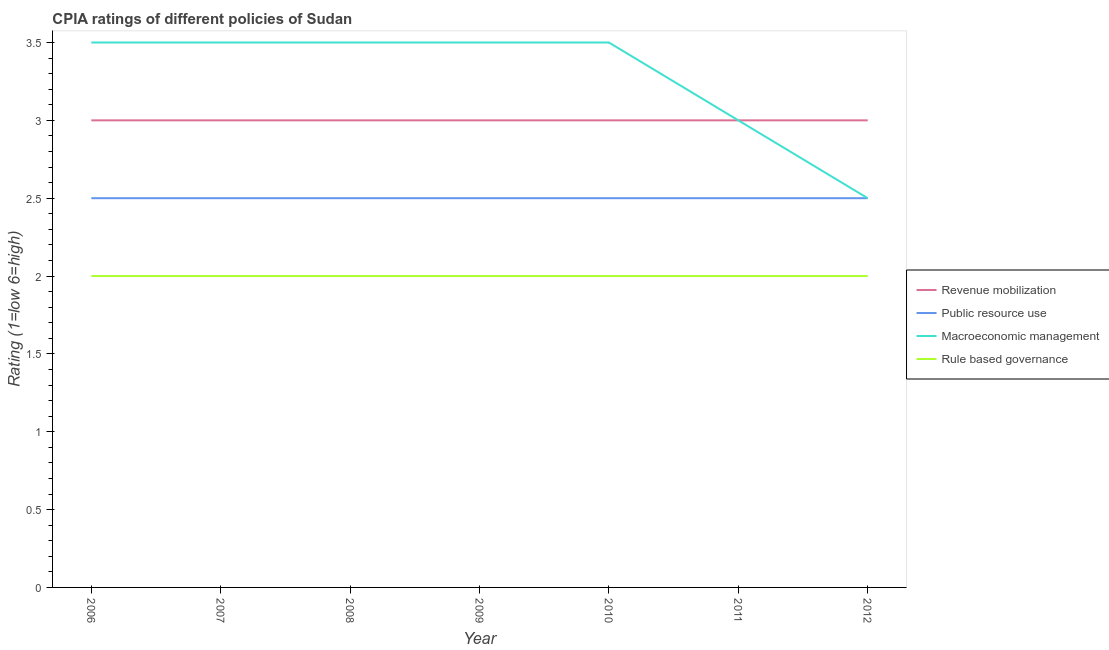How many different coloured lines are there?
Make the answer very short. 4. Does the line corresponding to cpia rating of revenue mobilization intersect with the line corresponding to cpia rating of rule based governance?
Offer a very short reply. No. What is the cpia rating of revenue mobilization in 2008?
Keep it short and to the point. 3. Across all years, what is the maximum cpia rating of revenue mobilization?
Your answer should be very brief. 3. Across all years, what is the minimum cpia rating of revenue mobilization?
Offer a very short reply. 3. In which year was the cpia rating of macroeconomic management maximum?
Provide a short and direct response. 2006. In which year was the cpia rating of public resource use minimum?
Your answer should be compact. 2006. What is the difference between the cpia rating of public resource use in 2009 and that in 2012?
Keep it short and to the point. 0. What is the difference between the cpia rating of rule based governance in 2006 and the cpia rating of macroeconomic management in 2010?
Keep it short and to the point. -1.5. What is the ratio of the cpia rating of revenue mobilization in 2007 to that in 2009?
Provide a succinct answer. 1. In how many years, is the cpia rating of public resource use greater than the average cpia rating of public resource use taken over all years?
Give a very brief answer. 0. Is it the case that in every year, the sum of the cpia rating of macroeconomic management and cpia rating of public resource use is greater than the sum of cpia rating of rule based governance and cpia rating of revenue mobilization?
Ensure brevity in your answer.  No. Does the cpia rating of rule based governance monotonically increase over the years?
Offer a very short reply. No. What is the difference between two consecutive major ticks on the Y-axis?
Give a very brief answer. 0.5. Does the graph contain any zero values?
Your response must be concise. No. Does the graph contain grids?
Your answer should be very brief. No. Where does the legend appear in the graph?
Offer a terse response. Center right. How many legend labels are there?
Your answer should be compact. 4. What is the title of the graph?
Keep it short and to the point. CPIA ratings of different policies of Sudan. Does "Public resource use" appear as one of the legend labels in the graph?
Offer a very short reply. Yes. What is the label or title of the X-axis?
Offer a very short reply. Year. What is the Rating (1=low 6=high) of Public resource use in 2006?
Provide a short and direct response. 2.5. What is the Rating (1=low 6=high) in Macroeconomic management in 2006?
Offer a very short reply. 3.5. What is the Rating (1=low 6=high) of Rule based governance in 2006?
Give a very brief answer. 2. What is the Rating (1=low 6=high) of Revenue mobilization in 2007?
Provide a short and direct response. 3. What is the Rating (1=low 6=high) of Rule based governance in 2007?
Make the answer very short. 2. What is the Rating (1=low 6=high) in Revenue mobilization in 2008?
Provide a succinct answer. 3. What is the Rating (1=low 6=high) in Macroeconomic management in 2008?
Your response must be concise. 3.5. What is the Rating (1=low 6=high) in Revenue mobilization in 2009?
Ensure brevity in your answer.  3. What is the Rating (1=low 6=high) in Public resource use in 2009?
Ensure brevity in your answer.  2.5. What is the Rating (1=low 6=high) of Macroeconomic management in 2009?
Offer a very short reply. 3.5. What is the Rating (1=low 6=high) of Rule based governance in 2009?
Offer a terse response. 2. What is the Rating (1=low 6=high) of Revenue mobilization in 2011?
Offer a terse response. 3. What is the Rating (1=low 6=high) in Public resource use in 2011?
Offer a terse response. 2.5. What is the Rating (1=low 6=high) of Macroeconomic management in 2011?
Provide a succinct answer. 3. What is the Rating (1=low 6=high) in Revenue mobilization in 2012?
Your answer should be very brief. 3. What is the Rating (1=low 6=high) in Macroeconomic management in 2012?
Your answer should be compact. 2.5. Across all years, what is the maximum Rating (1=low 6=high) of Public resource use?
Provide a short and direct response. 2.5. Across all years, what is the maximum Rating (1=low 6=high) in Rule based governance?
Provide a short and direct response. 2. Across all years, what is the minimum Rating (1=low 6=high) in Revenue mobilization?
Your answer should be compact. 3. What is the total Rating (1=low 6=high) in Macroeconomic management in the graph?
Offer a very short reply. 23. What is the difference between the Rating (1=low 6=high) in Macroeconomic management in 2006 and that in 2007?
Your answer should be compact. 0. What is the difference between the Rating (1=low 6=high) in Rule based governance in 2006 and that in 2007?
Keep it short and to the point. 0. What is the difference between the Rating (1=low 6=high) in Revenue mobilization in 2006 and that in 2008?
Provide a short and direct response. 0. What is the difference between the Rating (1=low 6=high) of Public resource use in 2006 and that in 2008?
Give a very brief answer. 0. What is the difference between the Rating (1=low 6=high) in Macroeconomic management in 2006 and that in 2008?
Ensure brevity in your answer.  0. What is the difference between the Rating (1=low 6=high) in Rule based governance in 2006 and that in 2008?
Offer a very short reply. 0. What is the difference between the Rating (1=low 6=high) of Revenue mobilization in 2006 and that in 2009?
Provide a short and direct response. 0. What is the difference between the Rating (1=low 6=high) in Public resource use in 2006 and that in 2009?
Provide a short and direct response. 0. What is the difference between the Rating (1=low 6=high) of Macroeconomic management in 2006 and that in 2009?
Your answer should be compact. 0. What is the difference between the Rating (1=low 6=high) in Rule based governance in 2006 and that in 2009?
Make the answer very short. 0. What is the difference between the Rating (1=low 6=high) in Revenue mobilization in 2006 and that in 2010?
Your answer should be compact. 0. What is the difference between the Rating (1=low 6=high) of Public resource use in 2006 and that in 2010?
Your response must be concise. 0. What is the difference between the Rating (1=low 6=high) in Rule based governance in 2006 and that in 2010?
Ensure brevity in your answer.  0. What is the difference between the Rating (1=low 6=high) in Public resource use in 2006 and that in 2011?
Make the answer very short. 0. What is the difference between the Rating (1=low 6=high) of Macroeconomic management in 2006 and that in 2011?
Make the answer very short. 0.5. What is the difference between the Rating (1=low 6=high) in Rule based governance in 2006 and that in 2011?
Your answer should be compact. 0. What is the difference between the Rating (1=low 6=high) of Revenue mobilization in 2006 and that in 2012?
Keep it short and to the point. 0. What is the difference between the Rating (1=low 6=high) of Macroeconomic management in 2006 and that in 2012?
Provide a short and direct response. 1. What is the difference between the Rating (1=low 6=high) of Rule based governance in 2006 and that in 2012?
Ensure brevity in your answer.  0. What is the difference between the Rating (1=low 6=high) of Revenue mobilization in 2007 and that in 2009?
Your answer should be compact. 0. What is the difference between the Rating (1=low 6=high) in Rule based governance in 2007 and that in 2009?
Provide a succinct answer. 0. What is the difference between the Rating (1=low 6=high) in Macroeconomic management in 2007 and that in 2010?
Provide a short and direct response. 0. What is the difference between the Rating (1=low 6=high) in Rule based governance in 2007 and that in 2010?
Your answer should be compact. 0. What is the difference between the Rating (1=low 6=high) of Public resource use in 2007 and that in 2011?
Provide a short and direct response. 0. What is the difference between the Rating (1=low 6=high) in Rule based governance in 2007 and that in 2011?
Offer a terse response. 0. What is the difference between the Rating (1=low 6=high) in Public resource use in 2007 and that in 2012?
Provide a short and direct response. 0. What is the difference between the Rating (1=low 6=high) in Macroeconomic management in 2007 and that in 2012?
Keep it short and to the point. 1. What is the difference between the Rating (1=low 6=high) of Rule based governance in 2007 and that in 2012?
Keep it short and to the point. 0. What is the difference between the Rating (1=low 6=high) in Revenue mobilization in 2008 and that in 2009?
Ensure brevity in your answer.  0. What is the difference between the Rating (1=low 6=high) in Macroeconomic management in 2008 and that in 2009?
Provide a short and direct response. 0. What is the difference between the Rating (1=low 6=high) of Public resource use in 2008 and that in 2010?
Your response must be concise. 0. What is the difference between the Rating (1=low 6=high) of Rule based governance in 2008 and that in 2010?
Provide a succinct answer. 0. What is the difference between the Rating (1=low 6=high) of Public resource use in 2008 and that in 2011?
Make the answer very short. 0. What is the difference between the Rating (1=low 6=high) in Macroeconomic management in 2008 and that in 2011?
Provide a short and direct response. 0.5. What is the difference between the Rating (1=low 6=high) of Rule based governance in 2008 and that in 2011?
Offer a very short reply. 0. What is the difference between the Rating (1=low 6=high) of Macroeconomic management in 2008 and that in 2012?
Keep it short and to the point. 1. What is the difference between the Rating (1=low 6=high) in Revenue mobilization in 2009 and that in 2010?
Offer a terse response. 0. What is the difference between the Rating (1=low 6=high) in Public resource use in 2009 and that in 2010?
Keep it short and to the point. 0. What is the difference between the Rating (1=low 6=high) in Macroeconomic management in 2009 and that in 2010?
Give a very brief answer. 0. What is the difference between the Rating (1=low 6=high) in Revenue mobilization in 2009 and that in 2011?
Keep it short and to the point. 0. What is the difference between the Rating (1=low 6=high) in Revenue mobilization in 2009 and that in 2012?
Offer a very short reply. 0. What is the difference between the Rating (1=low 6=high) in Rule based governance in 2010 and that in 2011?
Your response must be concise. 0. What is the difference between the Rating (1=low 6=high) of Public resource use in 2010 and that in 2012?
Your answer should be compact. 0. What is the difference between the Rating (1=low 6=high) in Macroeconomic management in 2010 and that in 2012?
Your answer should be compact. 1. What is the difference between the Rating (1=low 6=high) in Public resource use in 2011 and that in 2012?
Offer a very short reply. 0. What is the difference between the Rating (1=low 6=high) of Macroeconomic management in 2011 and that in 2012?
Make the answer very short. 0.5. What is the difference between the Rating (1=low 6=high) of Revenue mobilization in 2006 and the Rating (1=low 6=high) of Public resource use in 2007?
Offer a terse response. 0.5. What is the difference between the Rating (1=low 6=high) of Public resource use in 2006 and the Rating (1=low 6=high) of Macroeconomic management in 2007?
Make the answer very short. -1. What is the difference between the Rating (1=low 6=high) of Macroeconomic management in 2006 and the Rating (1=low 6=high) of Rule based governance in 2007?
Make the answer very short. 1.5. What is the difference between the Rating (1=low 6=high) in Revenue mobilization in 2006 and the Rating (1=low 6=high) in Public resource use in 2008?
Your response must be concise. 0.5. What is the difference between the Rating (1=low 6=high) in Revenue mobilization in 2006 and the Rating (1=low 6=high) in Rule based governance in 2008?
Your answer should be compact. 1. What is the difference between the Rating (1=low 6=high) of Public resource use in 2006 and the Rating (1=low 6=high) of Macroeconomic management in 2009?
Your response must be concise. -1. What is the difference between the Rating (1=low 6=high) in Macroeconomic management in 2006 and the Rating (1=low 6=high) in Rule based governance in 2009?
Keep it short and to the point. 1.5. What is the difference between the Rating (1=low 6=high) of Revenue mobilization in 2006 and the Rating (1=low 6=high) of Macroeconomic management in 2010?
Offer a very short reply. -0.5. What is the difference between the Rating (1=low 6=high) in Revenue mobilization in 2006 and the Rating (1=low 6=high) in Rule based governance in 2010?
Offer a terse response. 1. What is the difference between the Rating (1=low 6=high) in Public resource use in 2006 and the Rating (1=low 6=high) in Rule based governance in 2011?
Give a very brief answer. 0.5. What is the difference between the Rating (1=low 6=high) of Macroeconomic management in 2006 and the Rating (1=low 6=high) of Rule based governance in 2011?
Your answer should be very brief. 1.5. What is the difference between the Rating (1=low 6=high) of Revenue mobilization in 2006 and the Rating (1=low 6=high) of Macroeconomic management in 2012?
Give a very brief answer. 0.5. What is the difference between the Rating (1=low 6=high) in Macroeconomic management in 2006 and the Rating (1=low 6=high) in Rule based governance in 2012?
Give a very brief answer. 1.5. What is the difference between the Rating (1=low 6=high) of Public resource use in 2007 and the Rating (1=low 6=high) of Macroeconomic management in 2008?
Provide a succinct answer. -1. What is the difference between the Rating (1=low 6=high) of Revenue mobilization in 2007 and the Rating (1=low 6=high) of Public resource use in 2009?
Provide a succinct answer. 0.5. What is the difference between the Rating (1=low 6=high) of Revenue mobilization in 2007 and the Rating (1=low 6=high) of Rule based governance in 2009?
Offer a terse response. 1. What is the difference between the Rating (1=low 6=high) in Revenue mobilization in 2007 and the Rating (1=low 6=high) in Macroeconomic management in 2010?
Ensure brevity in your answer.  -0.5. What is the difference between the Rating (1=low 6=high) in Revenue mobilization in 2007 and the Rating (1=low 6=high) in Rule based governance in 2010?
Provide a short and direct response. 1. What is the difference between the Rating (1=low 6=high) of Public resource use in 2007 and the Rating (1=low 6=high) of Macroeconomic management in 2010?
Your answer should be very brief. -1. What is the difference between the Rating (1=low 6=high) of Public resource use in 2007 and the Rating (1=low 6=high) of Rule based governance in 2010?
Your response must be concise. 0.5. What is the difference between the Rating (1=low 6=high) of Revenue mobilization in 2007 and the Rating (1=low 6=high) of Public resource use in 2011?
Your answer should be very brief. 0.5. What is the difference between the Rating (1=low 6=high) of Public resource use in 2007 and the Rating (1=low 6=high) of Macroeconomic management in 2011?
Your answer should be very brief. -0.5. What is the difference between the Rating (1=low 6=high) of Macroeconomic management in 2007 and the Rating (1=low 6=high) of Rule based governance in 2011?
Your answer should be compact. 1.5. What is the difference between the Rating (1=low 6=high) in Revenue mobilization in 2007 and the Rating (1=low 6=high) in Public resource use in 2012?
Your answer should be very brief. 0.5. What is the difference between the Rating (1=low 6=high) in Revenue mobilization in 2007 and the Rating (1=low 6=high) in Rule based governance in 2012?
Give a very brief answer. 1. What is the difference between the Rating (1=low 6=high) of Public resource use in 2007 and the Rating (1=low 6=high) of Rule based governance in 2012?
Make the answer very short. 0.5. What is the difference between the Rating (1=low 6=high) in Macroeconomic management in 2008 and the Rating (1=low 6=high) in Rule based governance in 2009?
Give a very brief answer. 1.5. What is the difference between the Rating (1=low 6=high) in Revenue mobilization in 2008 and the Rating (1=low 6=high) in Public resource use in 2010?
Offer a terse response. 0.5. What is the difference between the Rating (1=low 6=high) of Revenue mobilization in 2008 and the Rating (1=low 6=high) of Macroeconomic management in 2010?
Keep it short and to the point. -0.5. What is the difference between the Rating (1=low 6=high) in Revenue mobilization in 2008 and the Rating (1=low 6=high) in Rule based governance in 2010?
Your answer should be compact. 1. What is the difference between the Rating (1=low 6=high) in Macroeconomic management in 2008 and the Rating (1=low 6=high) in Rule based governance in 2010?
Offer a very short reply. 1.5. What is the difference between the Rating (1=low 6=high) in Revenue mobilization in 2008 and the Rating (1=low 6=high) in Public resource use in 2011?
Give a very brief answer. 0.5. What is the difference between the Rating (1=low 6=high) of Public resource use in 2008 and the Rating (1=low 6=high) of Macroeconomic management in 2011?
Give a very brief answer. -0.5. What is the difference between the Rating (1=low 6=high) of Macroeconomic management in 2008 and the Rating (1=low 6=high) of Rule based governance in 2011?
Provide a succinct answer. 1.5. What is the difference between the Rating (1=low 6=high) in Revenue mobilization in 2008 and the Rating (1=low 6=high) in Public resource use in 2012?
Your answer should be very brief. 0.5. What is the difference between the Rating (1=low 6=high) of Revenue mobilization in 2008 and the Rating (1=low 6=high) of Macroeconomic management in 2012?
Make the answer very short. 0.5. What is the difference between the Rating (1=low 6=high) of Macroeconomic management in 2008 and the Rating (1=low 6=high) of Rule based governance in 2012?
Your answer should be compact. 1.5. What is the difference between the Rating (1=low 6=high) of Revenue mobilization in 2009 and the Rating (1=low 6=high) of Public resource use in 2010?
Give a very brief answer. 0.5. What is the difference between the Rating (1=low 6=high) in Public resource use in 2009 and the Rating (1=low 6=high) in Macroeconomic management in 2010?
Offer a terse response. -1. What is the difference between the Rating (1=low 6=high) in Public resource use in 2009 and the Rating (1=low 6=high) in Rule based governance in 2010?
Your answer should be very brief. 0.5. What is the difference between the Rating (1=low 6=high) of Public resource use in 2009 and the Rating (1=low 6=high) of Macroeconomic management in 2011?
Keep it short and to the point. -0.5. What is the difference between the Rating (1=low 6=high) in Public resource use in 2009 and the Rating (1=low 6=high) in Rule based governance in 2011?
Your answer should be very brief. 0.5. What is the difference between the Rating (1=low 6=high) in Macroeconomic management in 2009 and the Rating (1=low 6=high) in Rule based governance in 2011?
Provide a succinct answer. 1.5. What is the difference between the Rating (1=low 6=high) in Revenue mobilization in 2009 and the Rating (1=low 6=high) in Public resource use in 2012?
Offer a very short reply. 0.5. What is the difference between the Rating (1=low 6=high) of Revenue mobilization in 2009 and the Rating (1=low 6=high) of Rule based governance in 2012?
Your answer should be compact. 1. What is the difference between the Rating (1=low 6=high) of Public resource use in 2009 and the Rating (1=low 6=high) of Macroeconomic management in 2012?
Your answer should be very brief. 0. What is the difference between the Rating (1=low 6=high) in Macroeconomic management in 2009 and the Rating (1=low 6=high) in Rule based governance in 2012?
Make the answer very short. 1.5. What is the difference between the Rating (1=low 6=high) of Revenue mobilization in 2010 and the Rating (1=low 6=high) of Public resource use in 2011?
Provide a short and direct response. 0.5. What is the difference between the Rating (1=low 6=high) in Public resource use in 2010 and the Rating (1=low 6=high) in Macroeconomic management in 2011?
Provide a short and direct response. -0.5. What is the difference between the Rating (1=low 6=high) in Public resource use in 2010 and the Rating (1=low 6=high) in Rule based governance in 2011?
Your response must be concise. 0.5. What is the difference between the Rating (1=low 6=high) in Revenue mobilization in 2010 and the Rating (1=low 6=high) in Public resource use in 2012?
Provide a short and direct response. 0.5. What is the difference between the Rating (1=low 6=high) in Revenue mobilization in 2010 and the Rating (1=low 6=high) in Rule based governance in 2012?
Offer a terse response. 1. What is the difference between the Rating (1=low 6=high) in Public resource use in 2010 and the Rating (1=low 6=high) in Macroeconomic management in 2012?
Keep it short and to the point. 0. What is the difference between the Rating (1=low 6=high) in Public resource use in 2010 and the Rating (1=low 6=high) in Rule based governance in 2012?
Provide a succinct answer. 0.5. What is the difference between the Rating (1=low 6=high) of Macroeconomic management in 2010 and the Rating (1=low 6=high) of Rule based governance in 2012?
Offer a very short reply. 1.5. What is the difference between the Rating (1=low 6=high) of Revenue mobilization in 2011 and the Rating (1=low 6=high) of Rule based governance in 2012?
Your answer should be very brief. 1. What is the difference between the Rating (1=low 6=high) in Public resource use in 2011 and the Rating (1=low 6=high) in Macroeconomic management in 2012?
Ensure brevity in your answer.  0. What is the difference between the Rating (1=low 6=high) in Public resource use in 2011 and the Rating (1=low 6=high) in Rule based governance in 2012?
Make the answer very short. 0.5. What is the average Rating (1=low 6=high) of Revenue mobilization per year?
Offer a terse response. 3. What is the average Rating (1=low 6=high) of Public resource use per year?
Your answer should be very brief. 2.5. What is the average Rating (1=low 6=high) of Macroeconomic management per year?
Provide a short and direct response. 3.29. What is the average Rating (1=low 6=high) in Rule based governance per year?
Give a very brief answer. 2. In the year 2006, what is the difference between the Rating (1=low 6=high) of Public resource use and Rating (1=low 6=high) of Macroeconomic management?
Ensure brevity in your answer.  -1. In the year 2007, what is the difference between the Rating (1=low 6=high) in Revenue mobilization and Rating (1=low 6=high) in Public resource use?
Provide a succinct answer. 0.5. In the year 2007, what is the difference between the Rating (1=low 6=high) in Revenue mobilization and Rating (1=low 6=high) in Macroeconomic management?
Keep it short and to the point. -0.5. In the year 2007, what is the difference between the Rating (1=low 6=high) of Public resource use and Rating (1=low 6=high) of Macroeconomic management?
Your answer should be compact. -1. In the year 2007, what is the difference between the Rating (1=low 6=high) in Public resource use and Rating (1=low 6=high) in Rule based governance?
Give a very brief answer. 0.5. In the year 2007, what is the difference between the Rating (1=low 6=high) of Macroeconomic management and Rating (1=low 6=high) of Rule based governance?
Give a very brief answer. 1.5. In the year 2008, what is the difference between the Rating (1=low 6=high) of Revenue mobilization and Rating (1=low 6=high) of Macroeconomic management?
Give a very brief answer. -0.5. In the year 2008, what is the difference between the Rating (1=low 6=high) of Revenue mobilization and Rating (1=low 6=high) of Rule based governance?
Give a very brief answer. 1. In the year 2008, what is the difference between the Rating (1=low 6=high) of Macroeconomic management and Rating (1=low 6=high) of Rule based governance?
Give a very brief answer. 1.5. In the year 2009, what is the difference between the Rating (1=low 6=high) of Revenue mobilization and Rating (1=low 6=high) of Rule based governance?
Ensure brevity in your answer.  1. In the year 2009, what is the difference between the Rating (1=low 6=high) of Public resource use and Rating (1=low 6=high) of Macroeconomic management?
Ensure brevity in your answer.  -1. In the year 2009, what is the difference between the Rating (1=low 6=high) of Public resource use and Rating (1=low 6=high) of Rule based governance?
Provide a succinct answer. 0.5. In the year 2010, what is the difference between the Rating (1=low 6=high) in Revenue mobilization and Rating (1=low 6=high) in Public resource use?
Your response must be concise. 0.5. In the year 2010, what is the difference between the Rating (1=low 6=high) of Revenue mobilization and Rating (1=low 6=high) of Rule based governance?
Keep it short and to the point. 1. In the year 2010, what is the difference between the Rating (1=low 6=high) in Public resource use and Rating (1=low 6=high) in Macroeconomic management?
Offer a very short reply. -1. In the year 2010, what is the difference between the Rating (1=low 6=high) of Public resource use and Rating (1=low 6=high) of Rule based governance?
Keep it short and to the point. 0.5. In the year 2011, what is the difference between the Rating (1=low 6=high) of Revenue mobilization and Rating (1=low 6=high) of Macroeconomic management?
Provide a short and direct response. 0. In the year 2011, what is the difference between the Rating (1=low 6=high) in Macroeconomic management and Rating (1=low 6=high) in Rule based governance?
Offer a very short reply. 1. In the year 2012, what is the difference between the Rating (1=low 6=high) of Revenue mobilization and Rating (1=low 6=high) of Macroeconomic management?
Offer a very short reply. 0.5. In the year 2012, what is the difference between the Rating (1=low 6=high) of Revenue mobilization and Rating (1=low 6=high) of Rule based governance?
Keep it short and to the point. 1. In the year 2012, what is the difference between the Rating (1=low 6=high) of Macroeconomic management and Rating (1=low 6=high) of Rule based governance?
Offer a terse response. 0.5. What is the ratio of the Rating (1=low 6=high) of Macroeconomic management in 2006 to that in 2007?
Provide a short and direct response. 1. What is the ratio of the Rating (1=low 6=high) of Rule based governance in 2006 to that in 2007?
Provide a succinct answer. 1. What is the ratio of the Rating (1=low 6=high) in Macroeconomic management in 2006 to that in 2008?
Make the answer very short. 1. What is the ratio of the Rating (1=low 6=high) in Revenue mobilization in 2006 to that in 2009?
Offer a very short reply. 1. What is the ratio of the Rating (1=low 6=high) in Macroeconomic management in 2006 to that in 2009?
Keep it short and to the point. 1. What is the ratio of the Rating (1=low 6=high) of Public resource use in 2006 to that in 2010?
Keep it short and to the point. 1. What is the ratio of the Rating (1=low 6=high) in Macroeconomic management in 2006 to that in 2010?
Provide a short and direct response. 1. What is the ratio of the Rating (1=low 6=high) in Macroeconomic management in 2006 to that in 2011?
Your answer should be compact. 1.17. What is the ratio of the Rating (1=low 6=high) in Revenue mobilization in 2006 to that in 2012?
Provide a short and direct response. 1. What is the ratio of the Rating (1=low 6=high) in Public resource use in 2006 to that in 2012?
Your answer should be very brief. 1. What is the ratio of the Rating (1=low 6=high) in Macroeconomic management in 2006 to that in 2012?
Offer a terse response. 1.4. What is the ratio of the Rating (1=low 6=high) in Rule based governance in 2006 to that in 2012?
Provide a succinct answer. 1. What is the ratio of the Rating (1=low 6=high) of Revenue mobilization in 2007 to that in 2008?
Your answer should be compact. 1. What is the ratio of the Rating (1=low 6=high) in Public resource use in 2007 to that in 2008?
Offer a very short reply. 1. What is the ratio of the Rating (1=low 6=high) in Rule based governance in 2007 to that in 2008?
Your answer should be compact. 1. What is the ratio of the Rating (1=low 6=high) in Revenue mobilization in 2007 to that in 2009?
Give a very brief answer. 1. What is the ratio of the Rating (1=low 6=high) in Public resource use in 2007 to that in 2009?
Your answer should be very brief. 1. What is the ratio of the Rating (1=low 6=high) of Rule based governance in 2007 to that in 2009?
Give a very brief answer. 1. What is the ratio of the Rating (1=low 6=high) in Macroeconomic management in 2007 to that in 2010?
Provide a short and direct response. 1. What is the ratio of the Rating (1=low 6=high) in Rule based governance in 2007 to that in 2010?
Provide a short and direct response. 1. What is the ratio of the Rating (1=low 6=high) of Macroeconomic management in 2007 to that in 2011?
Provide a succinct answer. 1.17. What is the ratio of the Rating (1=low 6=high) of Rule based governance in 2007 to that in 2011?
Keep it short and to the point. 1. What is the ratio of the Rating (1=low 6=high) of Macroeconomic management in 2007 to that in 2012?
Ensure brevity in your answer.  1.4. What is the ratio of the Rating (1=low 6=high) in Rule based governance in 2007 to that in 2012?
Your answer should be compact. 1. What is the ratio of the Rating (1=low 6=high) in Revenue mobilization in 2008 to that in 2009?
Offer a terse response. 1. What is the ratio of the Rating (1=low 6=high) of Public resource use in 2008 to that in 2010?
Offer a terse response. 1. What is the ratio of the Rating (1=low 6=high) of Macroeconomic management in 2008 to that in 2010?
Offer a very short reply. 1. What is the ratio of the Rating (1=low 6=high) in Rule based governance in 2008 to that in 2010?
Provide a succinct answer. 1. What is the ratio of the Rating (1=low 6=high) of Macroeconomic management in 2008 to that in 2011?
Give a very brief answer. 1.17. What is the ratio of the Rating (1=low 6=high) in Rule based governance in 2008 to that in 2011?
Offer a very short reply. 1. What is the ratio of the Rating (1=low 6=high) in Revenue mobilization in 2008 to that in 2012?
Your answer should be very brief. 1. What is the ratio of the Rating (1=low 6=high) in Macroeconomic management in 2008 to that in 2012?
Your response must be concise. 1.4. What is the ratio of the Rating (1=low 6=high) in Rule based governance in 2008 to that in 2012?
Provide a succinct answer. 1. What is the ratio of the Rating (1=low 6=high) of Revenue mobilization in 2009 to that in 2010?
Provide a short and direct response. 1. What is the ratio of the Rating (1=low 6=high) of Public resource use in 2009 to that in 2010?
Offer a very short reply. 1. What is the ratio of the Rating (1=low 6=high) of Rule based governance in 2009 to that in 2010?
Provide a succinct answer. 1. What is the ratio of the Rating (1=low 6=high) in Public resource use in 2009 to that in 2011?
Keep it short and to the point. 1. What is the ratio of the Rating (1=low 6=high) of Revenue mobilization in 2009 to that in 2012?
Keep it short and to the point. 1. What is the ratio of the Rating (1=low 6=high) of Public resource use in 2009 to that in 2012?
Your answer should be very brief. 1. What is the ratio of the Rating (1=low 6=high) of Macroeconomic management in 2009 to that in 2012?
Your answer should be compact. 1.4. What is the ratio of the Rating (1=low 6=high) in Rule based governance in 2009 to that in 2012?
Keep it short and to the point. 1. What is the ratio of the Rating (1=low 6=high) of Revenue mobilization in 2010 to that in 2011?
Keep it short and to the point. 1. What is the ratio of the Rating (1=low 6=high) in Public resource use in 2010 to that in 2011?
Offer a very short reply. 1. What is the ratio of the Rating (1=low 6=high) of Revenue mobilization in 2010 to that in 2012?
Keep it short and to the point. 1. What is the ratio of the Rating (1=low 6=high) of Revenue mobilization in 2011 to that in 2012?
Provide a succinct answer. 1. What is the ratio of the Rating (1=low 6=high) in Macroeconomic management in 2011 to that in 2012?
Give a very brief answer. 1.2. What is the ratio of the Rating (1=low 6=high) of Rule based governance in 2011 to that in 2012?
Your response must be concise. 1. What is the difference between the highest and the second highest Rating (1=low 6=high) in Revenue mobilization?
Keep it short and to the point. 0. What is the difference between the highest and the second highest Rating (1=low 6=high) of Public resource use?
Offer a very short reply. 0. What is the difference between the highest and the second highest Rating (1=low 6=high) in Rule based governance?
Offer a very short reply. 0. What is the difference between the highest and the lowest Rating (1=low 6=high) in Public resource use?
Your response must be concise. 0. What is the difference between the highest and the lowest Rating (1=low 6=high) of Macroeconomic management?
Offer a very short reply. 1. 